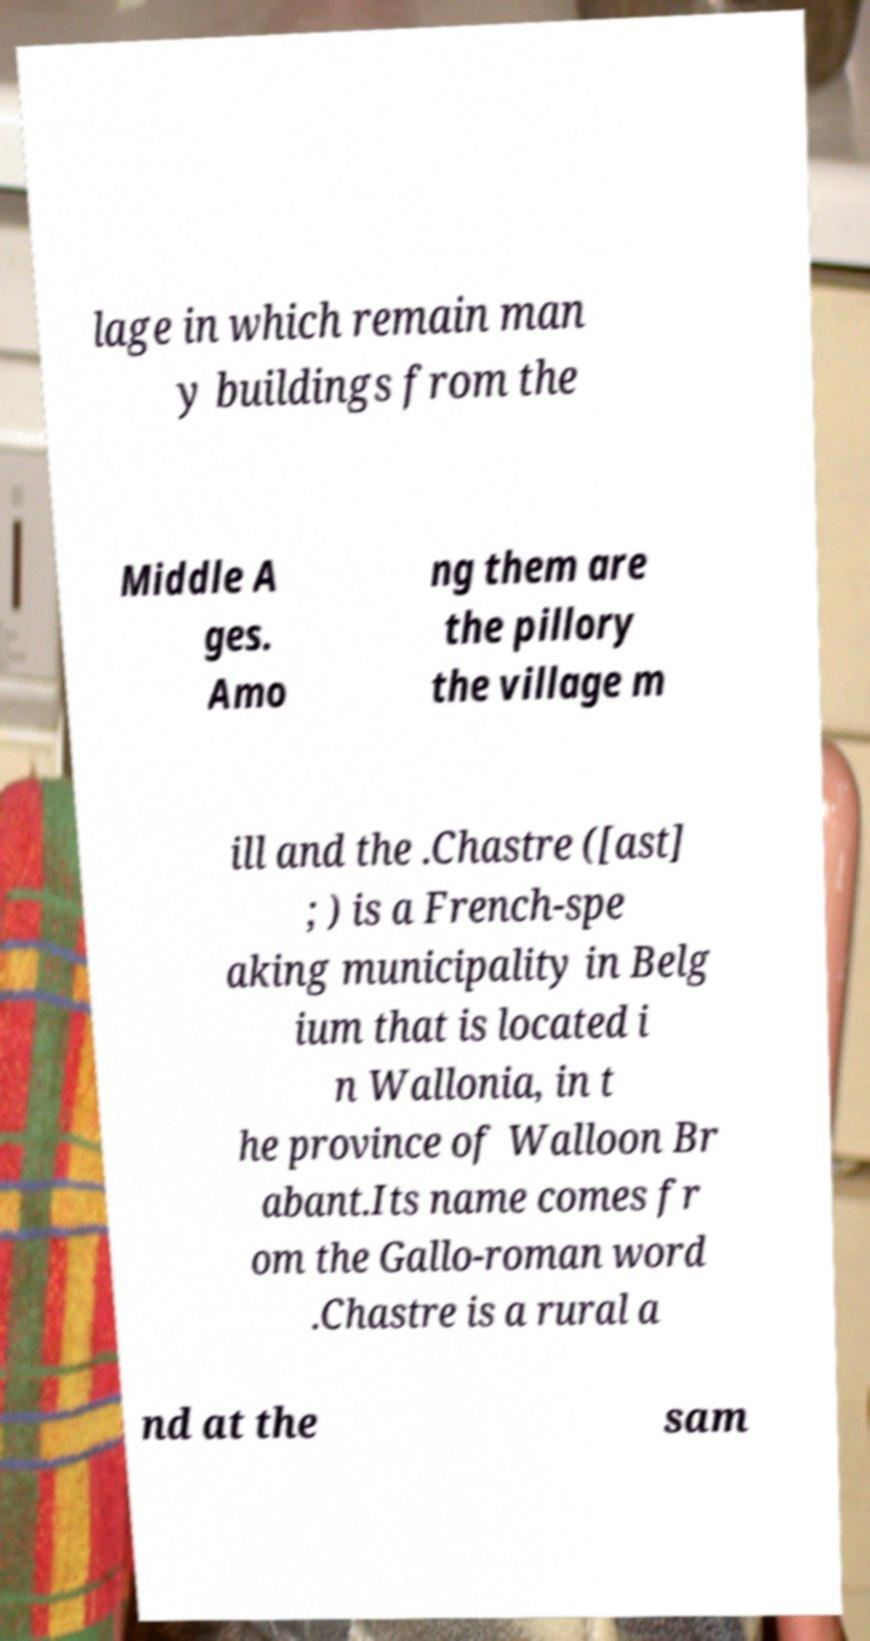What messages or text are displayed in this image? I need them in a readable, typed format. lage in which remain man y buildings from the Middle A ges. Amo ng them are the pillory the village m ill and the .Chastre ([ast] ; ) is a French-spe aking municipality in Belg ium that is located i n Wallonia, in t he province of Walloon Br abant.Its name comes fr om the Gallo-roman word .Chastre is a rural a nd at the sam 